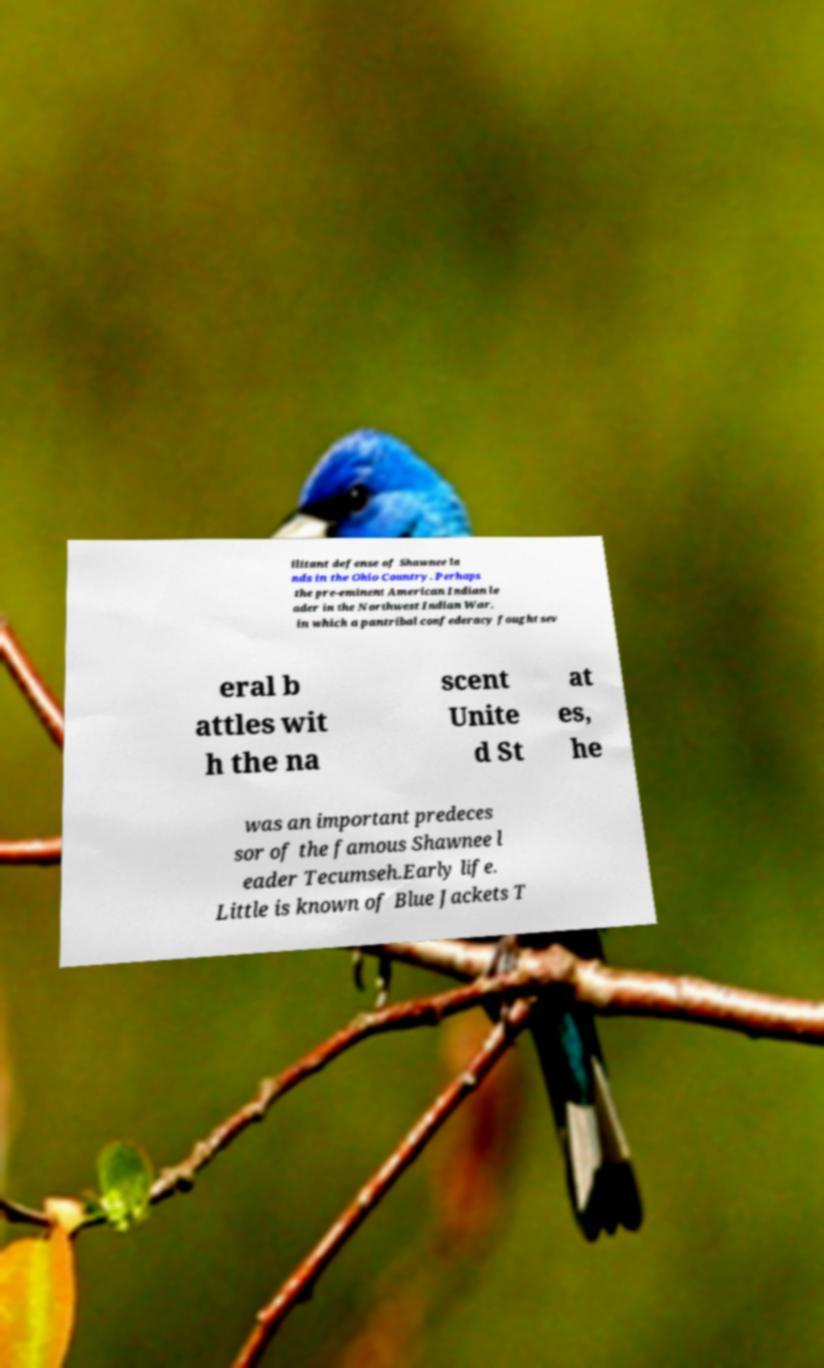What messages or text are displayed in this image? I need them in a readable, typed format. ilitant defense of Shawnee la nds in the Ohio Country. Perhaps the pre-eminent American Indian le ader in the Northwest Indian War, in which a pantribal confederacy fought sev eral b attles wit h the na scent Unite d St at es, he was an important predeces sor of the famous Shawnee l eader Tecumseh.Early life. Little is known of Blue Jackets T 